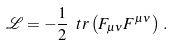<formula> <loc_0><loc_0><loc_500><loc_500>\mathcal { L } = - \frac { 1 } { 2 } \ t r \left ( F _ { \mu \nu } F ^ { \mu \nu } \right ) \, .</formula> 